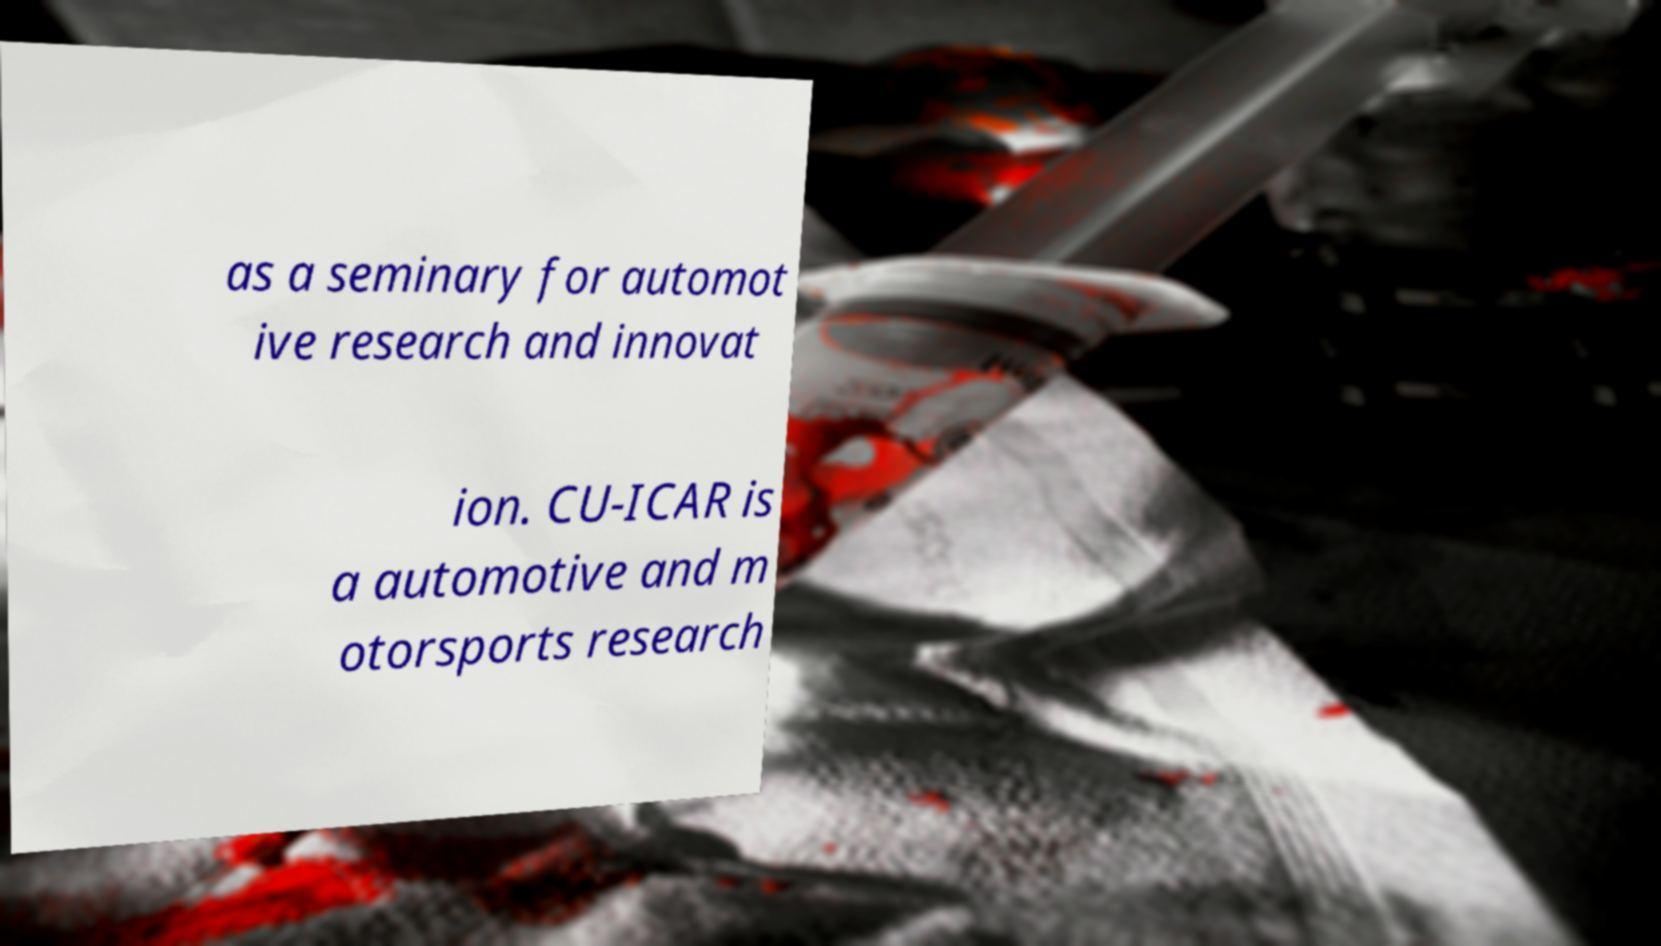Can you read and provide the text displayed in the image?This photo seems to have some interesting text. Can you extract and type it out for me? as a seminary for automot ive research and innovat ion. CU-ICAR is a automotive and m otorsports research 